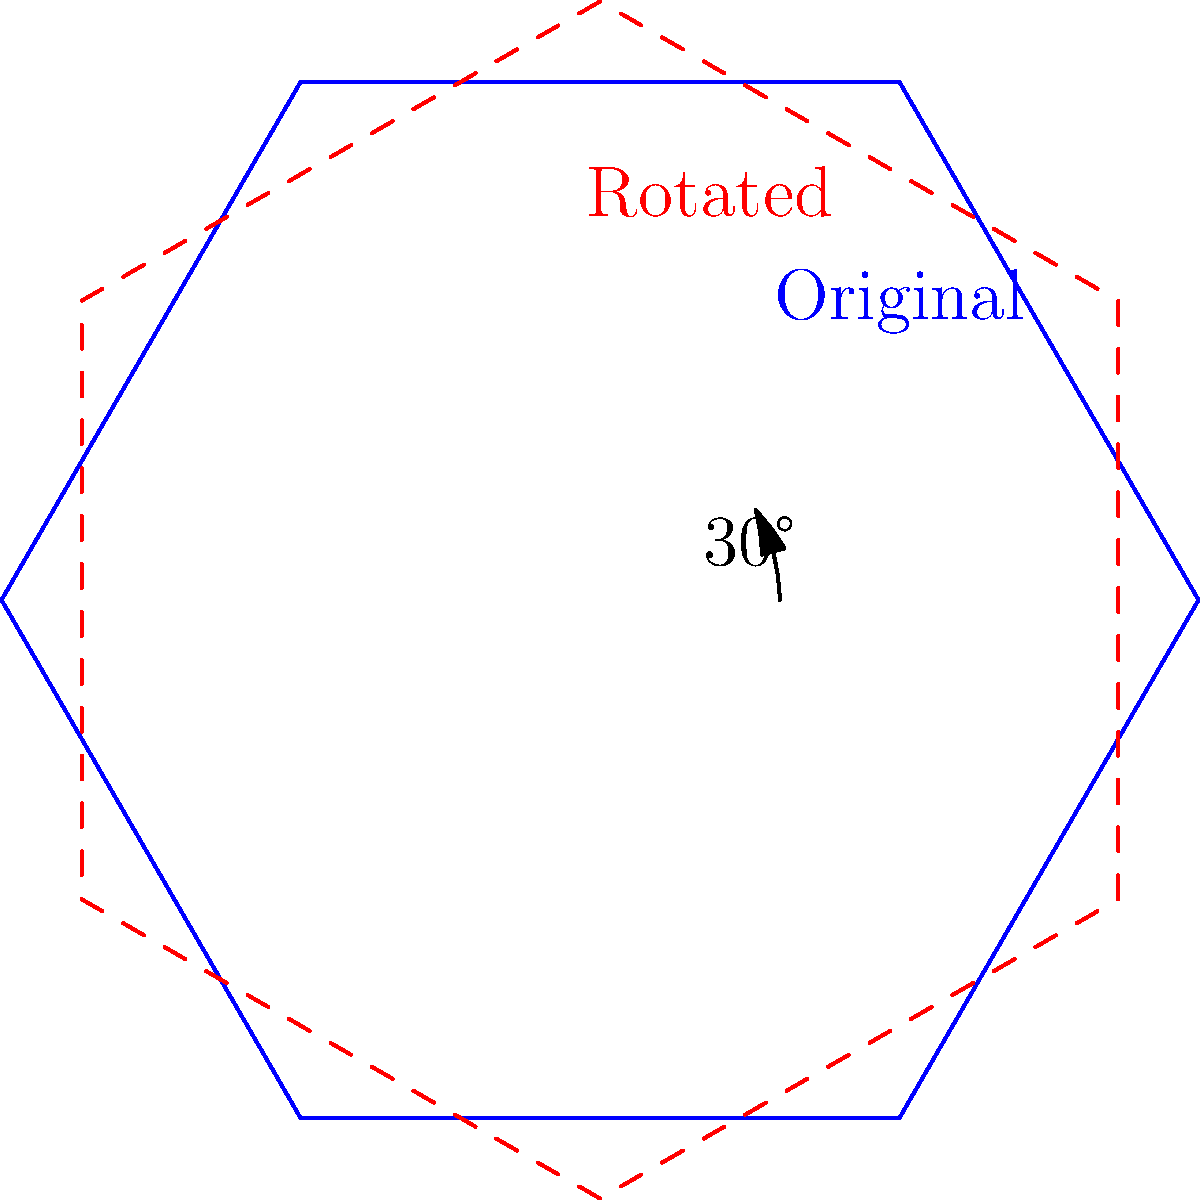As a local business owner, you're considering optimizing your factory floor plan to improve space usage. The current hexagonal layout is represented by the blue outline in the diagram. If you rotate the floor plan by 30° clockwise (shown by the red dashed line), what is the new coordinates of the point that was originally at $(1,0)$? To solve this problem, we'll use the rotation matrix for a clockwise rotation of 30°:

1) The rotation matrix for a clockwise rotation by $\theta$ is:
   $$R = \begin{pmatrix} \cos\theta & \sin\theta \\ -\sin\theta & \cos\theta \end{pmatrix}$$

2) For 30°, we have:
   $$R = \begin{pmatrix} \cos30° & \sin30° \\ -\sin30° & \cos30° \end{pmatrix} = \begin{pmatrix} \frac{\sqrt{3}}{2} & \frac{1}{2} \\ -\frac{1}{2} & \frac{\sqrt{3}}{2} \end{pmatrix}$$

3) The original point is $(1,0)$. We multiply this by the rotation matrix:
   $$\begin{pmatrix} \frac{\sqrt{3}}{2} & \frac{1}{2} \\ -\frac{1}{2} & \frac{\sqrt{3}}{2} \end{pmatrix} \begin{pmatrix} 1 \\ 0 \end{pmatrix} = \begin{pmatrix} \frac{\sqrt{3}}{2} \\ -\frac{1}{2} \end{pmatrix}$$

4) Therefore, the new coordinates are $(\frac{\sqrt{3}}{2}, -\frac{1}{2})$.
Answer: $(\frac{\sqrt{3}}{2}, -\frac{1}{2})$ 